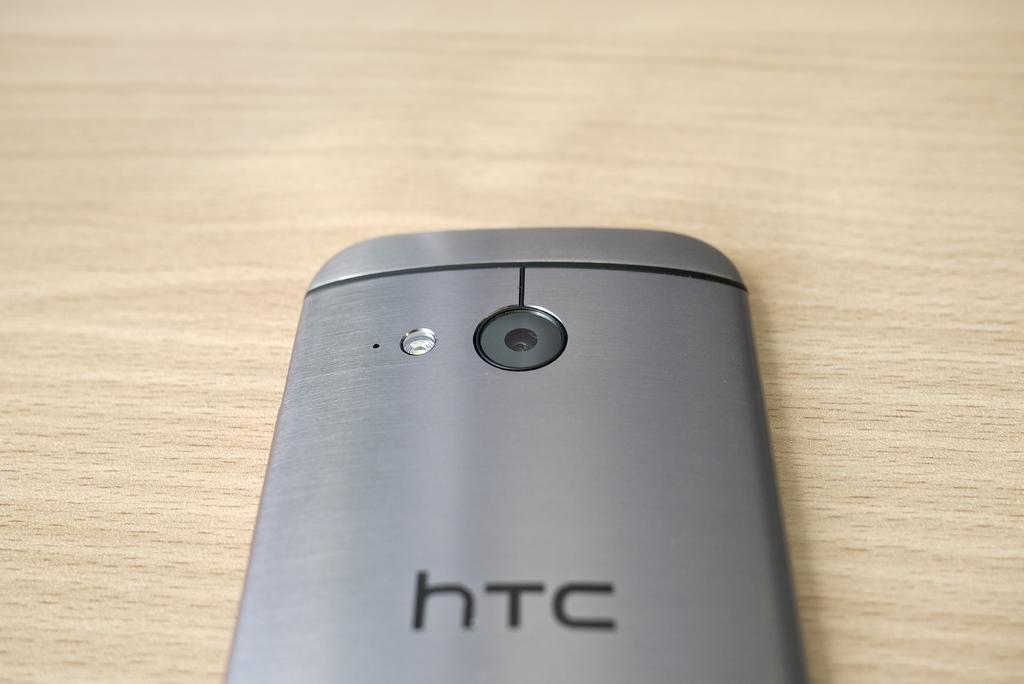<image>
Present a compact description of the photo's key features. A htc smart phone facing down on a wooden surface. 